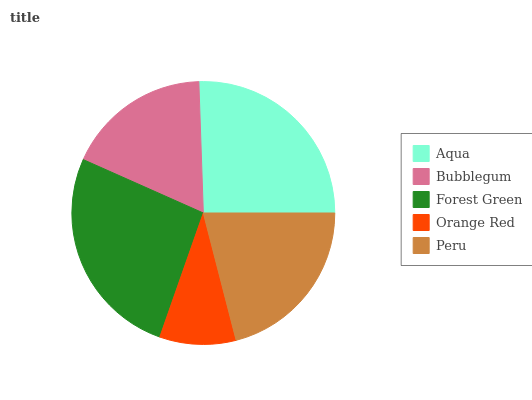Is Orange Red the minimum?
Answer yes or no. Yes. Is Forest Green the maximum?
Answer yes or no. Yes. Is Bubblegum the minimum?
Answer yes or no. No. Is Bubblegum the maximum?
Answer yes or no. No. Is Aqua greater than Bubblegum?
Answer yes or no. Yes. Is Bubblegum less than Aqua?
Answer yes or no. Yes. Is Bubblegum greater than Aqua?
Answer yes or no. No. Is Aqua less than Bubblegum?
Answer yes or no. No. Is Peru the high median?
Answer yes or no. Yes. Is Peru the low median?
Answer yes or no. Yes. Is Aqua the high median?
Answer yes or no. No. Is Orange Red the low median?
Answer yes or no. No. 